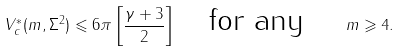<formula> <loc_0><loc_0><loc_500><loc_500>V _ { c } ^ { * } ( m , \Sigma ^ { 2 } ) \leqslant 6 \pi \left [ \frac { \gamma + 3 } { 2 } \right ] \quad \text {for any } \quad m \geqslant 4 .</formula> 